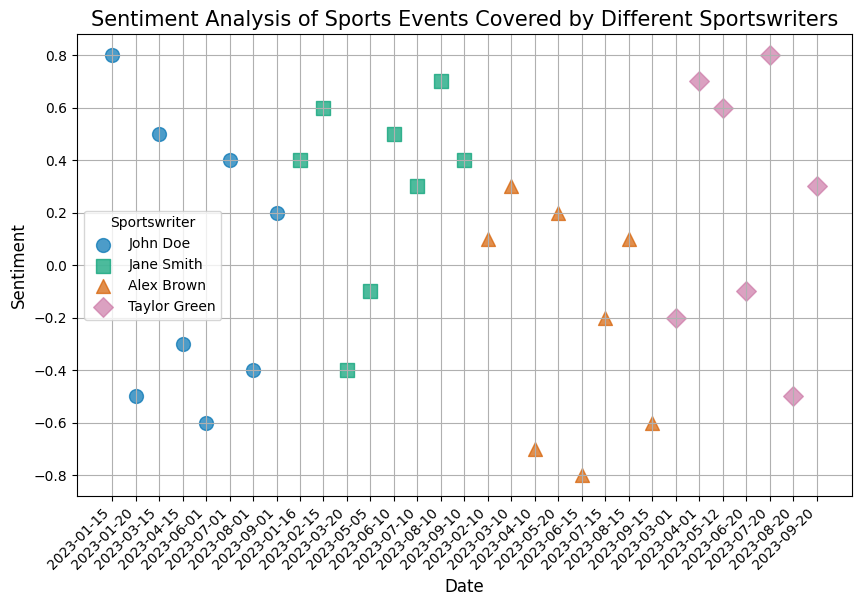What is the overall trend in John Doe's sentiments over time? By observing the scatter plot, we can trace John Doe’s plotted points over time. Initially, John Doe's sentiments are positive, but as time progresses, there are several instances where his sentiments are negative, indicating a downwards trend in some periods.
Answer: Downwards Trend Which sportswriter has the most negative sentiment value recorded, and what is the event? Looking at the most negatively placed point on the sentiment axis, we see the value -0.8. The scatter plot shows this value corresponds to Alex Brown during the "World Athletics Championships."
Answer: Alex Brown, World Athletics Championships During February 2023, were sentiments mostly positive or negative, and which sportswriters contributed to these sentiments? February 2023 spans two data points on the scatter plot: Alex Brown (0.1) covering "Winter Olympics Opening Ceremony" and Jane Smith (0.6) covering "Champions League Final". Both sentiments are positive.
Answer: Mostly Positive, Alex Brown and Jane Smith Compare the sentiment values of events covered by Taylor Green and Jane Smith in April 2023. Which sportswriter had more positive coverage? In April 2023, Taylor Green covered "Wimbledon Final" with a sentiment of 0.7, and Jane Smith covered "Masters Tournament" with a sentiment of -0.4. Comparatively, Taylor Green had more positive coverage.
Answer: Taylor Green How many sportswriters had more negative sentiments than positive ones overall? To determine the overall sentiments, we sum the sentiment values for each sportswriter and then count those with a cumulative negative sentiment. Over time, if we sum sentiments: John Doe (0.6, -0.5, 0.5, -0.3, -0.6, 0.4, -0.4, 0.2) = -0.1, Jane Smith (0.4, 0.6, -0.4, -0.1, 0.5, 0.7, 0.4, 0.3) = 2.4, Alex Brown (0.1, 0.3, -0.7, -0.8, 0.2, -0.2, 0.1, -0.5, -0.6) = -2.1, Taylor Green (-0.2, 0.6, -0.1, 0.8, 0.3) = 1.4. Therefore, John Doe and Alex Brown have negative sentiments overall.
Answer: Two sportswriters What is the difference between the highest and lowest sentiment values recorded, and which events are these values associated with? The highest sentiment value recorded is 0.8 seen in events by John Doe (Super Bowl LVII) and Taylor Green (Olympic Games Closing Ceremony). The lowest sentiment value is -0.8 by Alex Brown in the "World Athletics Championships". The difference is 0.8 - (-0.8) = 1.6.
Answer: 1.6 Who had the most positive sentiment for the Wimbledon Final, and what was that sentiment value? The scatter plot shows the sentiment values for Wimbledon Final covered by two sportswriters: Taylor Green (April 2023) with 0.7 and Jane Smith (August 2023) with 0.7. Both had the most positive sentiment for this event.
Answer: Taylor Green and Jane Smith, 0.7 Compare John Doe's sentiment for Super Bowl events in 2023 with his sentiment for the World Series. Which event had a more positive sentiment? John Doe covered "Super Bowl LVII" in January 2023 (0.8) and "Super Bowl LVIII" in August 2023 (-0.4). His sentiment for the "World Series" in September 2023 was 0.2. The event with a more positive sentiment was "Super Bowl LVII."
Answer: Super Bowl LVII What is the average sentiment value for all events covered by Jane Smith? To calculate Jane Smith's average sentiment: (0.4 + 0.6 - 0.4 - 0.1 + 0.5 + 0.7 + 0.4 + 0.3) / 8 = 2.4 / 8 = 0.3.
Answer: 0.3 